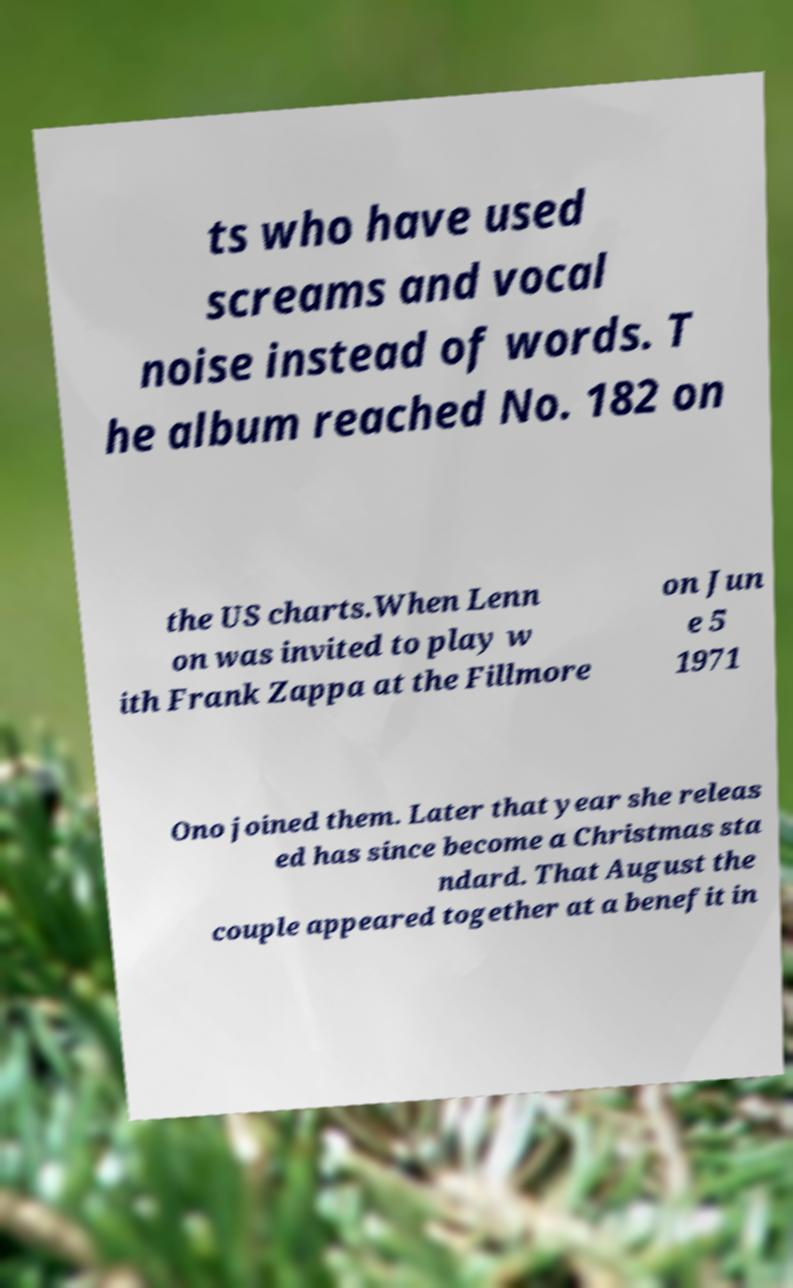What messages or text are displayed in this image? I need them in a readable, typed format. ts who have used screams and vocal noise instead of words. T he album reached No. 182 on the US charts.When Lenn on was invited to play w ith Frank Zappa at the Fillmore on Jun e 5 1971 Ono joined them. Later that year she releas ed has since become a Christmas sta ndard. That August the couple appeared together at a benefit in 